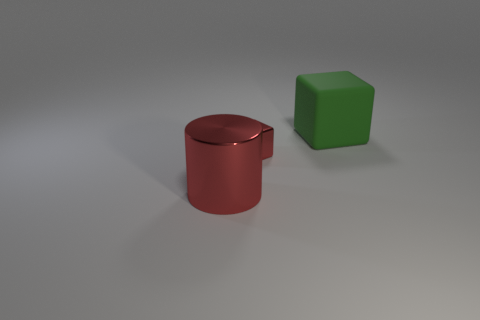Are there any other things that have the same size as the metallic block?
Give a very brief answer. No. Is the tiny metallic thing the same shape as the rubber object?
Give a very brief answer. Yes. The green matte object that is the same shape as the small red shiny object is what size?
Your answer should be compact. Large. There is a metal object that is to the left of the metallic cube; is it the same size as the tiny red object?
Provide a succinct answer. No. There is a cylinder that is the same color as the small shiny cube; what is its material?
Your response must be concise. Metal. What number of tiny objects are the same color as the big block?
Offer a terse response. 0. Is the number of big cylinders that are on the left side of the large red metal cylinder the same as the number of tiny purple rubber cubes?
Provide a succinct answer. Yes. The tiny shiny cube has what color?
Keep it short and to the point. Red. There is a red cube that is made of the same material as the red cylinder; what is its size?
Your answer should be compact. Small. The other thing that is the same material as the small red thing is what color?
Provide a succinct answer. Red. 